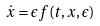Convert formula to latex. <formula><loc_0><loc_0><loc_500><loc_500>\dot { x } = \epsilon f ( t , x , \epsilon )</formula> 